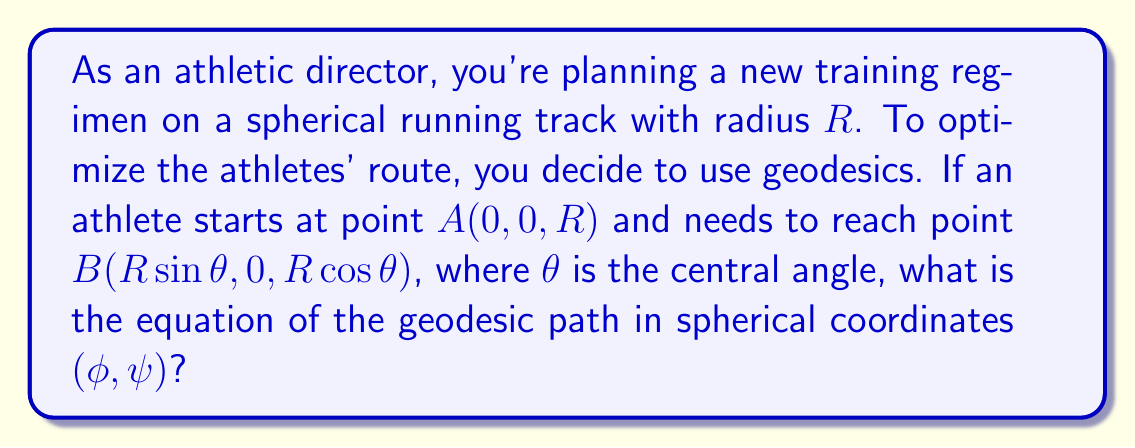Help me with this question. Let's approach this step-by-step:

1) On a sphere, geodesics are great circles. These are the largest circles that can be drawn on the surface of a sphere.

2) In spherical coordinates, a general great circle can be described by the equation:

   $$ \tan \psi = \tan \alpha \sin(\phi - \beta) $$

   where α is the inclination of the plane of the great circle to the equatorial plane, and β is the longitude of the ascending node.

3) Given our starting point A (0, 0, R) and ending point B (R sin θ, 0, R cos θ), we can determine:

   - A is at (φ, ψ) = (0, 0)
   - B is at (φ, ψ) = (0, θ)

4) Since both points lie on the xz-plane (y = 0), we know that β = 0. Our equation simplifies to:

   $$ \tan \psi = \tan \alpha \sin \phi $$

5) To find α, we can use the fact that the great circle passes through point B:

   $$ \tan \theta = \tan \alpha \sin 0 = 0 $$

   This implies that α = θ.

6) Therefore, our final equation for the geodesic is:

   $$ \tan \psi = \tan \theta \sin \phi $$

This equation describes the optimal path for the athlete to follow on the spherical track.
Answer: $\tan \psi = \tan \theta \sin \phi$ 